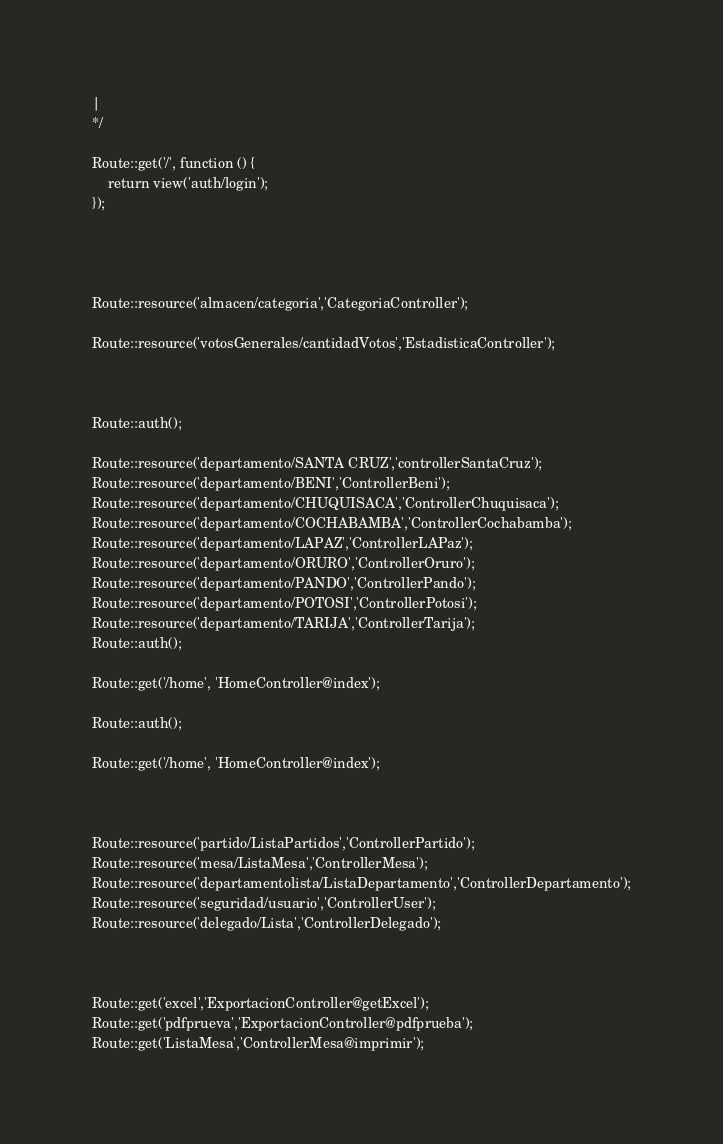<code> <loc_0><loc_0><loc_500><loc_500><_PHP_>|
*/

Route::get('/', function () {
    return view('auth/login');
});




Route::resource('almacen/categoria','CategoriaController');

Route::resource('votosGenerales/cantidadVotos','EstadisticaController');



Route::auth();

Route::resource('departamento/SANTA CRUZ','controllerSantaCruz');
Route::resource('departamento/BENI','ControllerBeni');
Route::resource('departamento/CHUQUISACA','ControllerChuquisaca');
Route::resource('departamento/COCHABAMBA','ControllerCochabamba');
Route::resource('departamento/LAPAZ','ControllerLAPaz');
Route::resource('departamento/ORURO','ControllerOruro');
Route::resource('departamento/PANDO','ControllerPando');
Route::resource('departamento/POTOSI','ControllerPotosi');
Route::resource('departamento/TARIJA','ControllerTarija');
Route::auth();

Route::get('/home', 'HomeController@index');

Route::auth();

Route::get('/home', 'HomeController@index');



Route::resource('partido/ListaPartidos','ControllerPartido');
Route::resource('mesa/ListaMesa','ControllerMesa');
Route::resource('departamentolista/ListaDepartamento','ControllerDepartamento');
Route::resource('seguridad/usuario','ControllerUser');
Route::resource('delegado/Lista','ControllerDelegado');



Route::get('excel','ExportacionController@getExcel');
Route::get('pdfprueva','ExportacionController@pdfprueba');
Route::get('ListaMesa','ControllerMesa@imprimir');</code> 